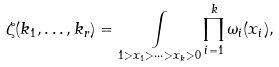<formula> <loc_0><loc_0><loc_500><loc_500>\zeta ( k _ { 1 } , \dots , k _ { r } ) = \underset { 1 > x _ { 1 } > \cdots > x _ { k } > 0 } { \int } \prod _ { i = 1 } ^ { k } \omega _ { i } ( x _ { i } ) ,</formula> 